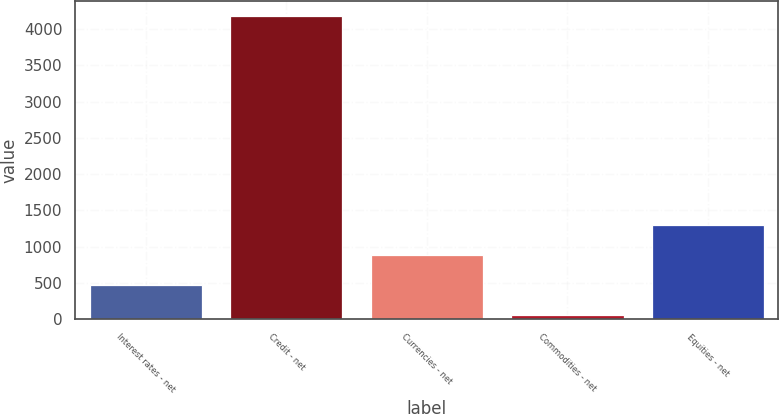<chart> <loc_0><loc_0><loc_500><loc_500><bar_chart><fcel>Interest rates - net<fcel>Credit - net<fcel>Currencies - net<fcel>Commodities - net<fcel>Equities - net<nl><fcel>471.6<fcel>4176<fcel>883.2<fcel>60<fcel>1294.8<nl></chart> 